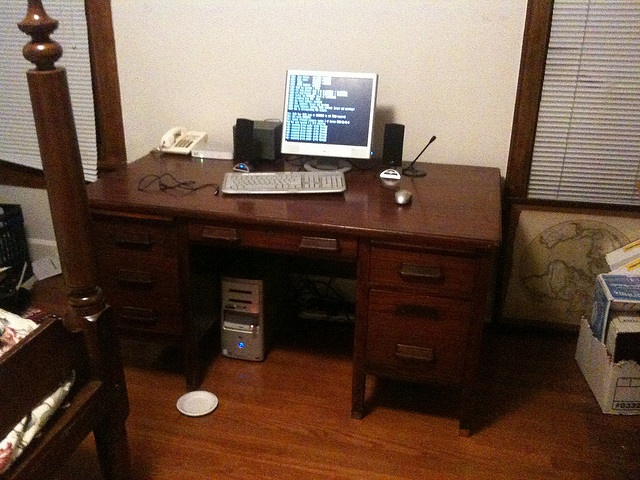Describe the objects in this image and their specific colors. I can see bed in darkgray, black, maroon, and beige tones, tv in darkgray, white, gray, and lightblue tones, keyboard in darkgray, lightgray, and gray tones, and mouse in darkgray, gray, and ivory tones in this image. 